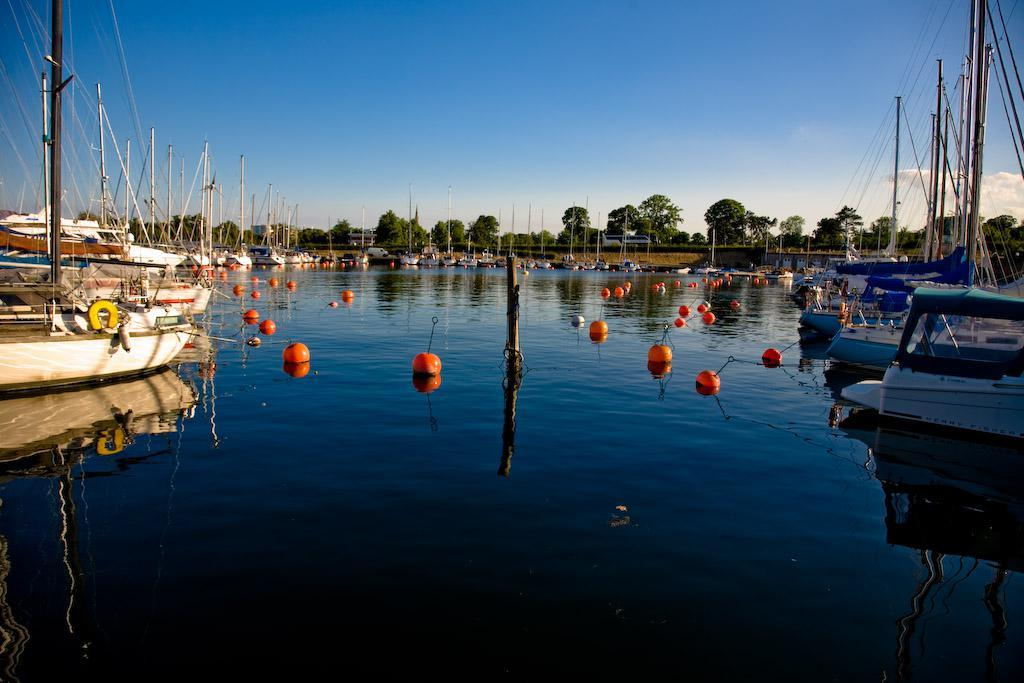What can be seen sticking up from the water in the image? There are poles in the image. What is on the water in the image? There are objects on the water in the image. What can be seen in the distance in the image? There are trees visible in the background of the image. What else is visible in the background of the image? The sky is visible in the background of the image. What can be seen on the boats in the image? There are poles on the boats in the image. What type of scarf is being used as bait in the image? There is no scarf or bait present in the image. What message of hope can be seen in the image? There is no message of hope depicted in the image. 